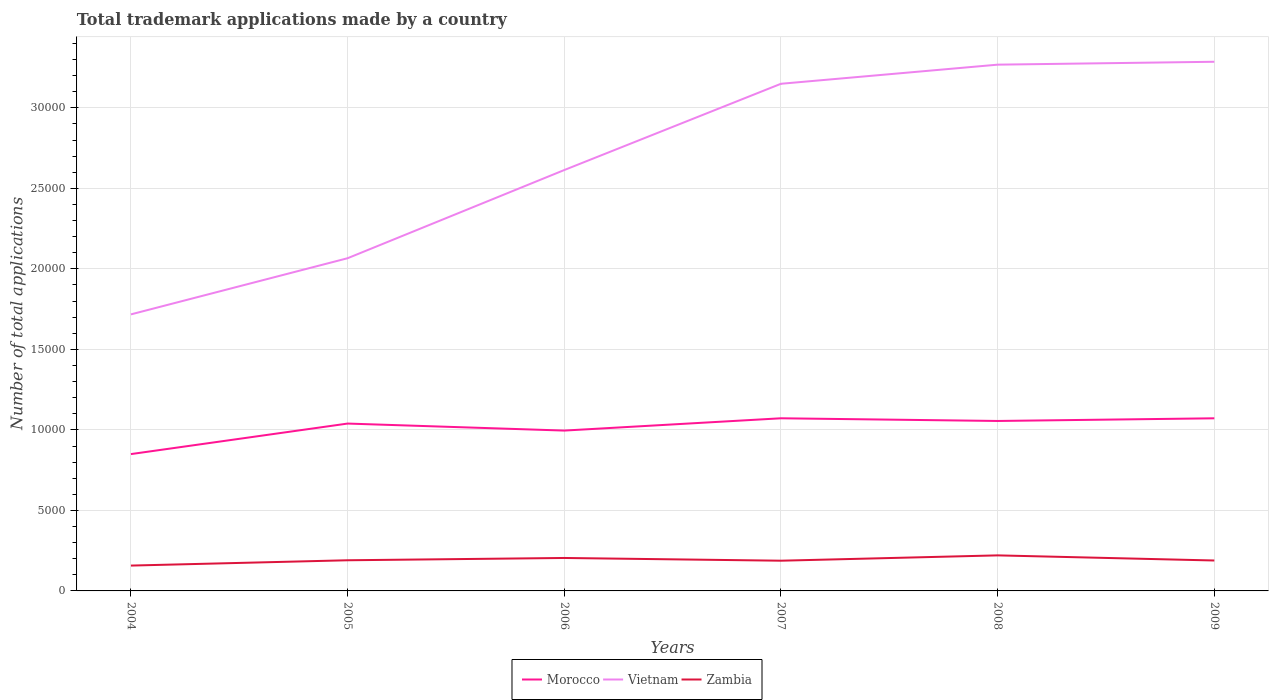Does the line corresponding to Morocco intersect with the line corresponding to Zambia?
Provide a short and direct response. No. Across all years, what is the maximum number of applications made by in Vietnam?
Provide a short and direct response. 1.72e+04. In which year was the number of applications made by in Morocco maximum?
Ensure brevity in your answer.  2004. What is the total number of applications made by in Zambia in the graph?
Ensure brevity in your answer.  158. What is the difference between the highest and the second highest number of applications made by in Morocco?
Provide a short and direct response. 2224. Are the values on the major ticks of Y-axis written in scientific E-notation?
Offer a terse response. No. Where does the legend appear in the graph?
Make the answer very short. Bottom center. What is the title of the graph?
Offer a terse response. Total trademark applications made by a country. What is the label or title of the Y-axis?
Keep it short and to the point. Number of total applications. What is the Number of total applications of Morocco in 2004?
Give a very brief answer. 8498. What is the Number of total applications of Vietnam in 2004?
Provide a short and direct response. 1.72e+04. What is the Number of total applications of Zambia in 2004?
Provide a succinct answer. 1574. What is the Number of total applications of Morocco in 2005?
Your response must be concise. 1.04e+04. What is the Number of total applications of Vietnam in 2005?
Offer a terse response. 2.07e+04. What is the Number of total applications in Zambia in 2005?
Offer a terse response. 1904. What is the Number of total applications of Morocco in 2006?
Offer a very short reply. 9958. What is the Number of total applications of Vietnam in 2006?
Give a very brief answer. 2.61e+04. What is the Number of total applications of Zambia in 2006?
Provide a succinct answer. 2047. What is the Number of total applications in Morocco in 2007?
Provide a short and direct response. 1.07e+04. What is the Number of total applications in Vietnam in 2007?
Keep it short and to the point. 3.15e+04. What is the Number of total applications in Zambia in 2007?
Give a very brief answer. 1877. What is the Number of total applications in Morocco in 2008?
Provide a short and direct response. 1.06e+04. What is the Number of total applications of Vietnam in 2008?
Make the answer very short. 3.27e+04. What is the Number of total applications in Zambia in 2008?
Keep it short and to the point. 2208. What is the Number of total applications in Morocco in 2009?
Offer a very short reply. 1.07e+04. What is the Number of total applications of Vietnam in 2009?
Your answer should be compact. 3.29e+04. What is the Number of total applications of Zambia in 2009?
Offer a very short reply. 1889. Across all years, what is the maximum Number of total applications of Morocco?
Make the answer very short. 1.07e+04. Across all years, what is the maximum Number of total applications in Vietnam?
Make the answer very short. 3.29e+04. Across all years, what is the maximum Number of total applications in Zambia?
Offer a terse response. 2208. Across all years, what is the minimum Number of total applications in Morocco?
Give a very brief answer. 8498. Across all years, what is the minimum Number of total applications of Vietnam?
Your answer should be compact. 1.72e+04. Across all years, what is the minimum Number of total applications in Zambia?
Ensure brevity in your answer.  1574. What is the total Number of total applications of Morocco in the graph?
Provide a succinct answer. 6.08e+04. What is the total Number of total applications of Vietnam in the graph?
Provide a succinct answer. 1.61e+05. What is the total Number of total applications in Zambia in the graph?
Ensure brevity in your answer.  1.15e+04. What is the difference between the Number of total applications of Morocco in 2004 and that in 2005?
Keep it short and to the point. -1896. What is the difference between the Number of total applications of Vietnam in 2004 and that in 2005?
Provide a succinct answer. -3488. What is the difference between the Number of total applications in Zambia in 2004 and that in 2005?
Offer a very short reply. -330. What is the difference between the Number of total applications in Morocco in 2004 and that in 2006?
Provide a short and direct response. -1460. What is the difference between the Number of total applications of Vietnam in 2004 and that in 2006?
Offer a very short reply. -8965. What is the difference between the Number of total applications in Zambia in 2004 and that in 2006?
Your answer should be compact. -473. What is the difference between the Number of total applications of Morocco in 2004 and that in 2007?
Provide a short and direct response. -2224. What is the difference between the Number of total applications of Vietnam in 2004 and that in 2007?
Make the answer very short. -1.43e+04. What is the difference between the Number of total applications of Zambia in 2004 and that in 2007?
Make the answer very short. -303. What is the difference between the Number of total applications in Morocco in 2004 and that in 2008?
Keep it short and to the point. -2057. What is the difference between the Number of total applications in Vietnam in 2004 and that in 2008?
Make the answer very short. -1.55e+04. What is the difference between the Number of total applications in Zambia in 2004 and that in 2008?
Make the answer very short. -634. What is the difference between the Number of total applications in Morocco in 2004 and that in 2009?
Ensure brevity in your answer.  -2223. What is the difference between the Number of total applications of Vietnam in 2004 and that in 2009?
Give a very brief answer. -1.57e+04. What is the difference between the Number of total applications of Zambia in 2004 and that in 2009?
Keep it short and to the point. -315. What is the difference between the Number of total applications of Morocco in 2005 and that in 2006?
Your answer should be compact. 436. What is the difference between the Number of total applications of Vietnam in 2005 and that in 2006?
Ensure brevity in your answer.  -5477. What is the difference between the Number of total applications of Zambia in 2005 and that in 2006?
Your answer should be compact. -143. What is the difference between the Number of total applications of Morocco in 2005 and that in 2007?
Offer a very short reply. -328. What is the difference between the Number of total applications in Vietnam in 2005 and that in 2007?
Your answer should be very brief. -1.08e+04. What is the difference between the Number of total applications of Morocco in 2005 and that in 2008?
Offer a very short reply. -161. What is the difference between the Number of total applications in Vietnam in 2005 and that in 2008?
Make the answer very short. -1.20e+04. What is the difference between the Number of total applications in Zambia in 2005 and that in 2008?
Your answer should be very brief. -304. What is the difference between the Number of total applications in Morocco in 2005 and that in 2009?
Keep it short and to the point. -327. What is the difference between the Number of total applications in Vietnam in 2005 and that in 2009?
Offer a very short reply. -1.22e+04. What is the difference between the Number of total applications in Morocco in 2006 and that in 2007?
Keep it short and to the point. -764. What is the difference between the Number of total applications of Vietnam in 2006 and that in 2007?
Your answer should be compact. -5357. What is the difference between the Number of total applications of Zambia in 2006 and that in 2007?
Ensure brevity in your answer.  170. What is the difference between the Number of total applications of Morocco in 2006 and that in 2008?
Offer a very short reply. -597. What is the difference between the Number of total applications in Vietnam in 2006 and that in 2008?
Give a very brief answer. -6544. What is the difference between the Number of total applications in Zambia in 2006 and that in 2008?
Provide a short and direct response. -161. What is the difference between the Number of total applications in Morocco in 2006 and that in 2009?
Give a very brief answer. -763. What is the difference between the Number of total applications in Vietnam in 2006 and that in 2009?
Make the answer very short. -6724. What is the difference between the Number of total applications in Zambia in 2006 and that in 2009?
Your answer should be compact. 158. What is the difference between the Number of total applications in Morocco in 2007 and that in 2008?
Offer a very short reply. 167. What is the difference between the Number of total applications of Vietnam in 2007 and that in 2008?
Give a very brief answer. -1187. What is the difference between the Number of total applications of Zambia in 2007 and that in 2008?
Your response must be concise. -331. What is the difference between the Number of total applications of Morocco in 2007 and that in 2009?
Keep it short and to the point. 1. What is the difference between the Number of total applications in Vietnam in 2007 and that in 2009?
Ensure brevity in your answer.  -1367. What is the difference between the Number of total applications in Morocco in 2008 and that in 2009?
Provide a short and direct response. -166. What is the difference between the Number of total applications of Vietnam in 2008 and that in 2009?
Provide a succinct answer. -180. What is the difference between the Number of total applications of Zambia in 2008 and that in 2009?
Offer a very short reply. 319. What is the difference between the Number of total applications of Morocco in 2004 and the Number of total applications of Vietnam in 2005?
Offer a very short reply. -1.22e+04. What is the difference between the Number of total applications of Morocco in 2004 and the Number of total applications of Zambia in 2005?
Your response must be concise. 6594. What is the difference between the Number of total applications of Vietnam in 2004 and the Number of total applications of Zambia in 2005?
Offer a terse response. 1.53e+04. What is the difference between the Number of total applications of Morocco in 2004 and the Number of total applications of Vietnam in 2006?
Your response must be concise. -1.76e+04. What is the difference between the Number of total applications in Morocco in 2004 and the Number of total applications in Zambia in 2006?
Provide a succinct answer. 6451. What is the difference between the Number of total applications in Vietnam in 2004 and the Number of total applications in Zambia in 2006?
Ensure brevity in your answer.  1.51e+04. What is the difference between the Number of total applications of Morocco in 2004 and the Number of total applications of Vietnam in 2007?
Make the answer very short. -2.30e+04. What is the difference between the Number of total applications of Morocco in 2004 and the Number of total applications of Zambia in 2007?
Make the answer very short. 6621. What is the difference between the Number of total applications of Vietnam in 2004 and the Number of total applications of Zambia in 2007?
Give a very brief answer. 1.53e+04. What is the difference between the Number of total applications in Morocco in 2004 and the Number of total applications in Vietnam in 2008?
Give a very brief answer. -2.42e+04. What is the difference between the Number of total applications of Morocco in 2004 and the Number of total applications of Zambia in 2008?
Keep it short and to the point. 6290. What is the difference between the Number of total applications of Vietnam in 2004 and the Number of total applications of Zambia in 2008?
Ensure brevity in your answer.  1.50e+04. What is the difference between the Number of total applications of Morocco in 2004 and the Number of total applications of Vietnam in 2009?
Your response must be concise. -2.44e+04. What is the difference between the Number of total applications in Morocco in 2004 and the Number of total applications in Zambia in 2009?
Offer a very short reply. 6609. What is the difference between the Number of total applications in Vietnam in 2004 and the Number of total applications in Zambia in 2009?
Keep it short and to the point. 1.53e+04. What is the difference between the Number of total applications of Morocco in 2005 and the Number of total applications of Vietnam in 2006?
Offer a terse response. -1.57e+04. What is the difference between the Number of total applications in Morocco in 2005 and the Number of total applications in Zambia in 2006?
Your answer should be compact. 8347. What is the difference between the Number of total applications of Vietnam in 2005 and the Number of total applications of Zambia in 2006?
Offer a terse response. 1.86e+04. What is the difference between the Number of total applications of Morocco in 2005 and the Number of total applications of Vietnam in 2007?
Offer a terse response. -2.11e+04. What is the difference between the Number of total applications of Morocco in 2005 and the Number of total applications of Zambia in 2007?
Give a very brief answer. 8517. What is the difference between the Number of total applications in Vietnam in 2005 and the Number of total applications in Zambia in 2007?
Offer a terse response. 1.88e+04. What is the difference between the Number of total applications of Morocco in 2005 and the Number of total applications of Vietnam in 2008?
Make the answer very short. -2.23e+04. What is the difference between the Number of total applications of Morocco in 2005 and the Number of total applications of Zambia in 2008?
Offer a terse response. 8186. What is the difference between the Number of total applications in Vietnam in 2005 and the Number of total applications in Zambia in 2008?
Your answer should be compact. 1.85e+04. What is the difference between the Number of total applications in Morocco in 2005 and the Number of total applications in Vietnam in 2009?
Your answer should be compact. -2.25e+04. What is the difference between the Number of total applications of Morocco in 2005 and the Number of total applications of Zambia in 2009?
Make the answer very short. 8505. What is the difference between the Number of total applications in Vietnam in 2005 and the Number of total applications in Zambia in 2009?
Keep it short and to the point. 1.88e+04. What is the difference between the Number of total applications of Morocco in 2006 and the Number of total applications of Vietnam in 2007?
Your answer should be compact. -2.15e+04. What is the difference between the Number of total applications of Morocco in 2006 and the Number of total applications of Zambia in 2007?
Give a very brief answer. 8081. What is the difference between the Number of total applications of Vietnam in 2006 and the Number of total applications of Zambia in 2007?
Provide a short and direct response. 2.43e+04. What is the difference between the Number of total applications in Morocco in 2006 and the Number of total applications in Vietnam in 2008?
Provide a short and direct response. -2.27e+04. What is the difference between the Number of total applications of Morocco in 2006 and the Number of total applications of Zambia in 2008?
Keep it short and to the point. 7750. What is the difference between the Number of total applications of Vietnam in 2006 and the Number of total applications of Zambia in 2008?
Keep it short and to the point. 2.39e+04. What is the difference between the Number of total applications in Morocco in 2006 and the Number of total applications in Vietnam in 2009?
Ensure brevity in your answer.  -2.29e+04. What is the difference between the Number of total applications of Morocco in 2006 and the Number of total applications of Zambia in 2009?
Give a very brief answer. 8069. What is the difference between the Number of total applications in Vietnam in 2006 and the Number of total applications in Zambia in 2009?
Your answer should be very brief. 2.43e+04. What is the difference between the Number of total applications in Morocco in 2007 and the Number of total applications in Vietnam in 2008?
Keep it short and to the point. -2.20e+04. What is the difference between the Number of total applications of Morocco in 2007 and the Number of total applications of Zambia in 2008?
Keep it short and to the point. 8514. What is the difference between the Number of total applications of Vietnam in 2007 and the Number of total applications of Zambia in 2008?
Make the answer very short. 2.93e+04. What is the difference between the Number of total applications of Morocco in 2007 and the Number of total applications of Vietnam in 2009?
Keep it short and to the point. -2.21e+04. What is the difference between the Number of total applications of Morocco in 2007 and the Number of total applications of Zambia in 2009?
Keep it short and to the point. 8833. What is the difference between the Number of total applications in Vietnam in 2007 and the Number of total applications in Zambia in 2009?
Provide a short and direct response. 2.96e+04. What is the difference between the Number of total applications of Morocco in 2008 and the Number of total applications of Vietnam in 2009?
Offer a very short reply. -2.23e+04. What is the difference between the Number of total applications in Morocco in 2008 and the Number of total applications in Zambia in 2009?
Offer a very short reply. 8666. What is the difference between the Number of total applications in Vietnam in 2008 and the Number of total applications in Zambia in 2009?
Your answer should be compact. 3.08e+04. What is the average Number of total applications in Morocco per year?
Ensure brevity in your answer.  1.01e+04. What is the average Number of total applications of Vietnam per year?
Give a very brief answer. 2.68e+04. What is the average Number of total applications of Zambia per year?
Offer a terse response. 1916.5. In the year 2004, what is the difference between the Number of total applications in Morocco and Number of total applications in Vietnam?
Your answer should be compact. -8677. In the year 2004, what is the difference between the Number of total applications of Morocco and Number of total applications of Zambia?
Offer a terse response. 6924. In the year 2004, what is the difference between the Number of total applications in Vietnam and Number of total applications in Zambia?
Offer a terse response. 1.56e+04. In the year 2005, what is the difference between the Number of total applications of Morocco and Number of total applications of Vietnam?
Provide a short and direct response. -1.03e+04. In the year 2005, what is the difference between the Number of total applications of Morocco and Number of total applications of Zambia?
Offer a terse response. 8490. In the year 2005, what is the difference between the Number of total applications in Vietnam and Number of total applications in Zambia?
Make the answer very short. 1.88e+04. In the year 2006, what is the difference between the Number of total applications in Morocco and Number of total applications in Vietnam?
Provide a succinct answer. -1.62e+04. In the year 2006, what is the difference between the Number of total applications of Morocco and Number of total applications of Zambia?
Your answer should be compact. 7911. In the year 2006, what is the difference between the Number of total applications in Vietnam and Number of total applications in Zambia?
Provide a short and direct response. 2.41e+04. In the year 2007, what is the difference between the Number of total applications of Morocco and Number of total applications of Vietnam?
Provide a short and direct response. -2.08e+04. In the year 2007, what is the difference between the Number of total applications in Morocco and Number of total applications in Zambia?
Keep it short and to the point. 8845. In the year 2007, what is the difference between the Number of total applications of Vietnam and Number of total applications of Zambia?
Your response must be concise. 2.96e+04. In the year 2008, what is the difference between the Number of total applications of Morocco and Number of total applications of Vietnam?
Make the answer very short. -2.21e+04. In the year 2008, what is the difference between the Number of total applications in Morocco and Number of total applications in Zambia?
Provide a succinct answer. 8347. In the year 2008, what is the difference between the Number of total applications in Vietnam and Number of total applications in Zambia?
Your answer should be compact. 3.05e+04. In the year 2009, what is the difference between the Number of total applications in Morocco and Number of total applications in Vietnam?
Keep it short and to the point. -2.21e+04. In the year 2009, what is the difference between the Number of total applications in Morocco and Number of total applications in Zambia?
Make the answer very short. 8832. In the year 2009, what is the difference between the Number of total applications in Vietnam and Number of total applications in Zambia?
Keep it short and to the point. 3.10e+04. What is the ratio of the Number of total applications in Morocco in 2004 to that in 2005?
Provide a succinct answer. 0.82. What is the ratio of the Number of total applications of Vietnam in 2004 to that in 2005?
Provide a short and direct response. 0.83. What is the ratio of the Number of total applications of Zambia in 2004 to that in 2005?
Ensure brevity in your answer.  0.83. What is the ratio of the Number of total applications of Morocco in 2004 to that in 2006?
Ensure brevity in your answer.  0.85. What is the ratio of the Number of total applications in Vietnam in 2004 to that in 2006?
Ensure brevity in your answer.  0.66. What is the ratio of the Number of total applications in Zambia in 2004 to that in 2006?
Offer a terse response. 0.77. What is the ratio of the Number of total applications in Morocco in 2004 to that in 2007?
Provide a short and direct response. 0.79. What is the ratio of the Number of total applications in Vietnam in 2004 to that in 2007?
Keep it short and to the point. 0.55. What is the ratio of the Number of total applications in Zambia in 2004 to that in 2007?
Provide a short and direct response. 0.84. What is the ratio of the Number of total applications in Morocco in 2004 to that in 2008?
Ensure brevity in your answer.  0.81. What is the ratio of the Number of total applications of Vietnam in 2004 to that in 2008?
Give a very brief answer. 0.53. What is the ratio of the Number of total applications in Zambia in 2004 to that in 2008?
Ensure brevity in your answer.  0.71. What is the ratio of the Number of total applications of Morocco in 2004 to that in 2009?
Give a very brief answer. 0.79. What is the ratio of the Number of total applications of Vietnam in 2004 to that in 2009?
Provide a succinct answer. 0.52. What is the ratio of the Number of total applications in Zambia in 2004 to that in 2009?
Offer a very short reply. 0.83. What is the ratio of the Number of total applications of Morocco in 2005 to that in 2006?
Make the answer very short. 1.04. What is the ratio of the Number of total applications of Vietnam in 2005 to that in 2006?
Ensure brevity in your answer.  0.79. What is the ratio of the Number of total applications in Zambia in 2005 to that in 2006?
Keep it short and to the point. 0.93. What is the ratio of the Number of total applications in Morocco in 2005 to that in 2007?
Ensure brevity in your answer.  0.97. What is the ratio of the Number of total applications of Vietnam in 2005 to that in 2007?
Your response must be concise. 0.66. What is the ratio of the Number of total applications in Zambia in 2005 to that in 2007?
Your answer should be very brief. 1.01. What is the ratio of the Number of total applications of Morocco in 2005 to that in 2008?
Provide a succinct answer. 0.98. What is the ratio of the Number of total applications of Vietnam in 2005 to that in 2008?
Offer a terse response. 0.63. What is the ratio of the Number of total applications of Zambia in 2005 to that in 2008?
Offer a very short reply. 0.86. What is the ratio of the Number of total applications of Morocco in 2005 to that in 2009?
Ensure brevity in your answer.  0.97. What is the ratio of the Number of total applications in Vietnam in 2005 to that in 2009?
Your answer should be very brief. 0.63. What is the ratio of the Number of total applications in Zambia in 2005 to that in 2009?
Offer a terse response. 1.01. What is the ratio of the Number of total applications in Morocco in 2006 to that in 2007?
Keep it short and to the point. 0.93. What is the ratio of the Number of total applications in Vietnam in 2006 to that in 2007?
Ensure brevity in your answer.  0.83. What is the ratio of the Number of total applications in Zambia in 2006 to that in 2007?
Provide a short and direct response. 1.09. What is the ratio of the Number of total applications of Morocco in 2006 to that in 2008?
Make the answer very short. 0.94. What is the ratio of the Number of total applications in Vietnam in 2006 to that in 2008?
Make the answer very short. 0.8. What is the ratio of the Number of total applications in Zambia in 2006 to that in 2008?
Your response must be concise. 0.93. What is the ratio of the Number of total applications of Morocco in 2006 to that in 2009?
Provide a succinct answer. 0.93. What is the ratio of the Number of total applications in Vietnam in 2006 to that in 2009?
Give a very brief answer. 0.8. What is the ratio of the Number of total applications in Zambia in 2006 to that in 2009?
Offer a very short reply. 1.08. What is the ratio of the Number of total applications of Morocco in 2007 to that in 2008?
Provide a succinct answer. 1.02. What is the ratio of the Number of total applications in Vietnam in 2007 to that in 2008?
Your response must be concise. 0.96. What is the ratio of the Number of total applications of Zambia in 2007 to that in 2008?
Keep it short and to the point. 0.85. What is the ratio of the Number of total applications of Morocco in 2007 to that in 2009?
Make the answer very short. 1. What is the ratio of the Number of total applications in Vietnam in 2007 to that in 2009?
Your response must be concise. 0.96. What is the ratio of the Number of total applications of Zambia in 2007 to that in 2009?
Provide a short and direct response. 0.99. What is the ratio of the Number of total applications of Morocco in 2008 to that in 2009?
Provide a succinct answer. 0.98. What is the ratio of the Number of total applications of Vietnam in 2008 to that in 2009?
Provide a succinct answer. 0.99. What is the ratio of the Number of total applications in Zambia in 2008 to that in 2009?
Ensure brevity in your answer.  1.17. What is the difference between the highest and the second highest Number of total applications of Morocco?
Provide a short and direct response. 1. What is the difference between the highest and the second highest Number of total applications in Vietnam?
Give a very brief answer. 180. What is the difference between the highest and the second highest Number of total applications in Zambia?
Your answer should be compact. 161. What is the difference between the highest and the lowest Number of total applications in Morocco?
Offer a terse response. 2224. What is the difference between the highest and the lowest Number of total applications of Vietnam?
Provide a short and direct response. 1.57e+04. What is the difference between the highest and the lowest Number of total applications of Zambia?
Offer a very short reply. 634. 